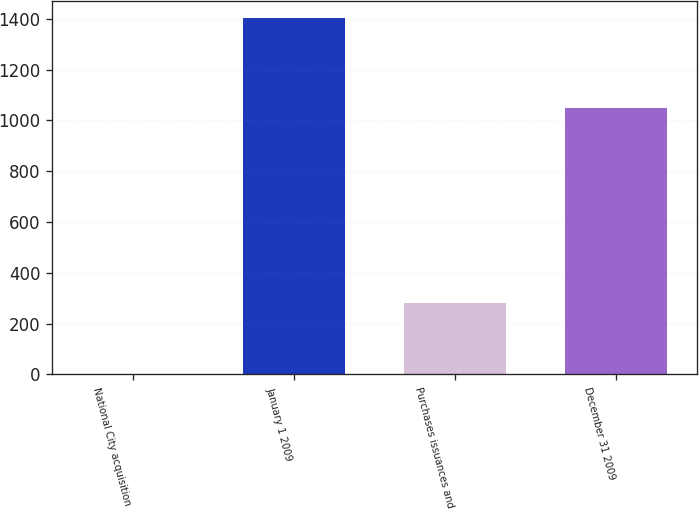Convert chart to OTSL. <chart><loc_0><loc_0><loc_500><loc_500><bar_chart><fcel>National City acquisition<fcel>January 1 2009<fcel>Purchases issuances and<fcel>December 31 2009<nl><fcel>1<fcel>1401<fcel>283<fcel>1050<nl></chart> 